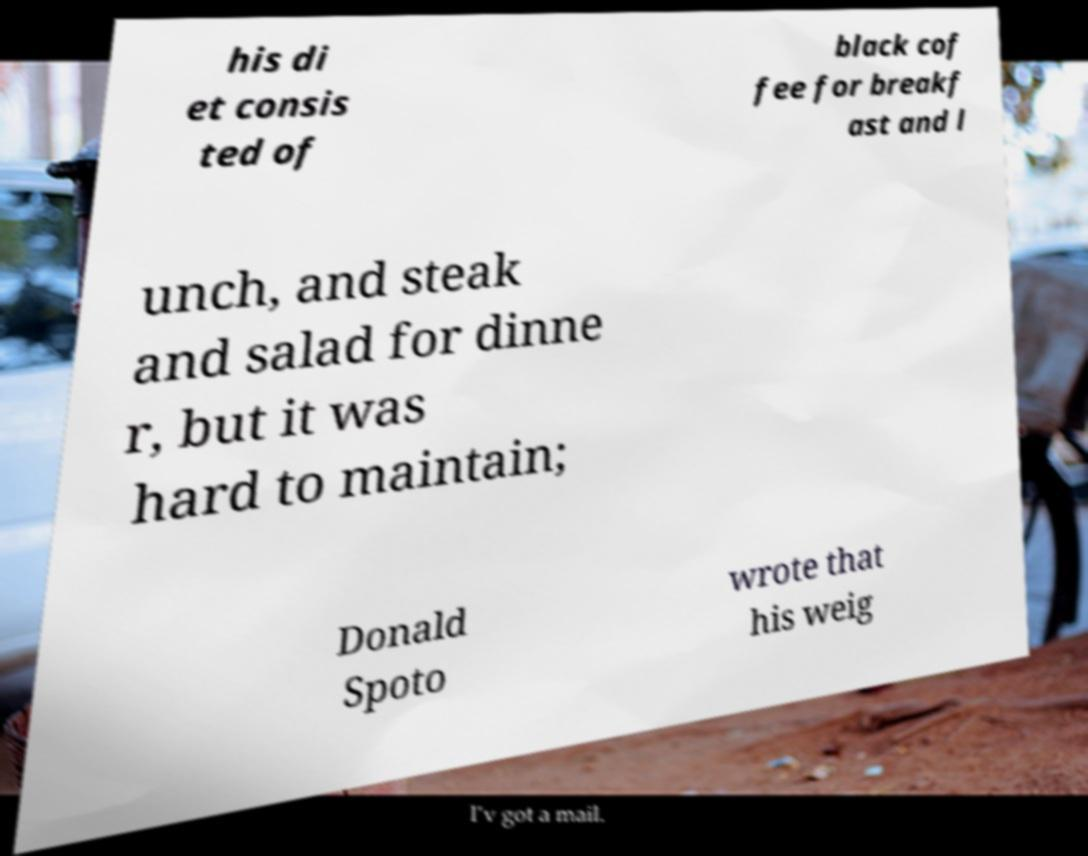Can you accurately transcribe the text from the provided image for me? his di et consis ted of black cof fee for breakf ast and l unch, and steak and salad for dinne r, but it was hard to maintain; Donald Spoto wrote that his weig 